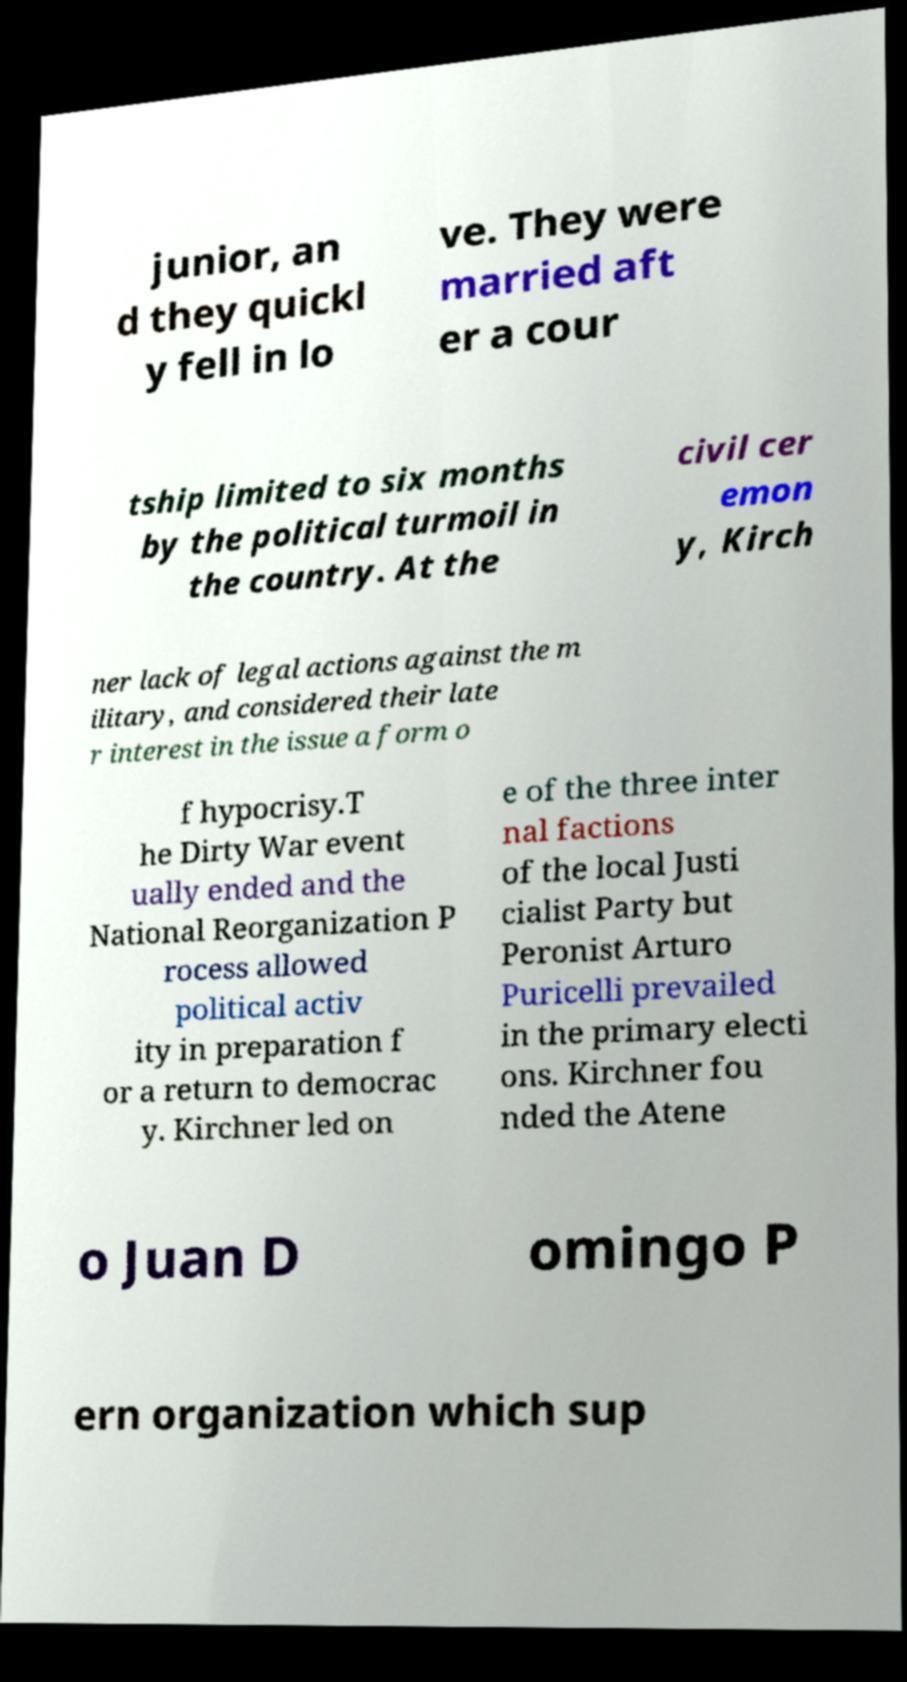Can you accurately transcribe the text from the provided image for me? junior, an d they quickl y fell in lo ve. They were married aft er a cour tship limited to six months by the political turmoil in the country. At the civil cer emon y, Kirch ner lack of legal actions against the m ilitary, and considered their late r interest in the issue a form o f hypocrisy.T he Dirty War event ually ended and the National Reorganization P rocess allowed political activ ity in preparation f or a return to democrac y. Kirchner led on e of the three inter nal factions of the local Justi cialist Party but Peronist Arturo Puricelli prevailed in the primary electi ons. Kirchner fou nded the Atene o Juan D omingo P ern organization which sup 